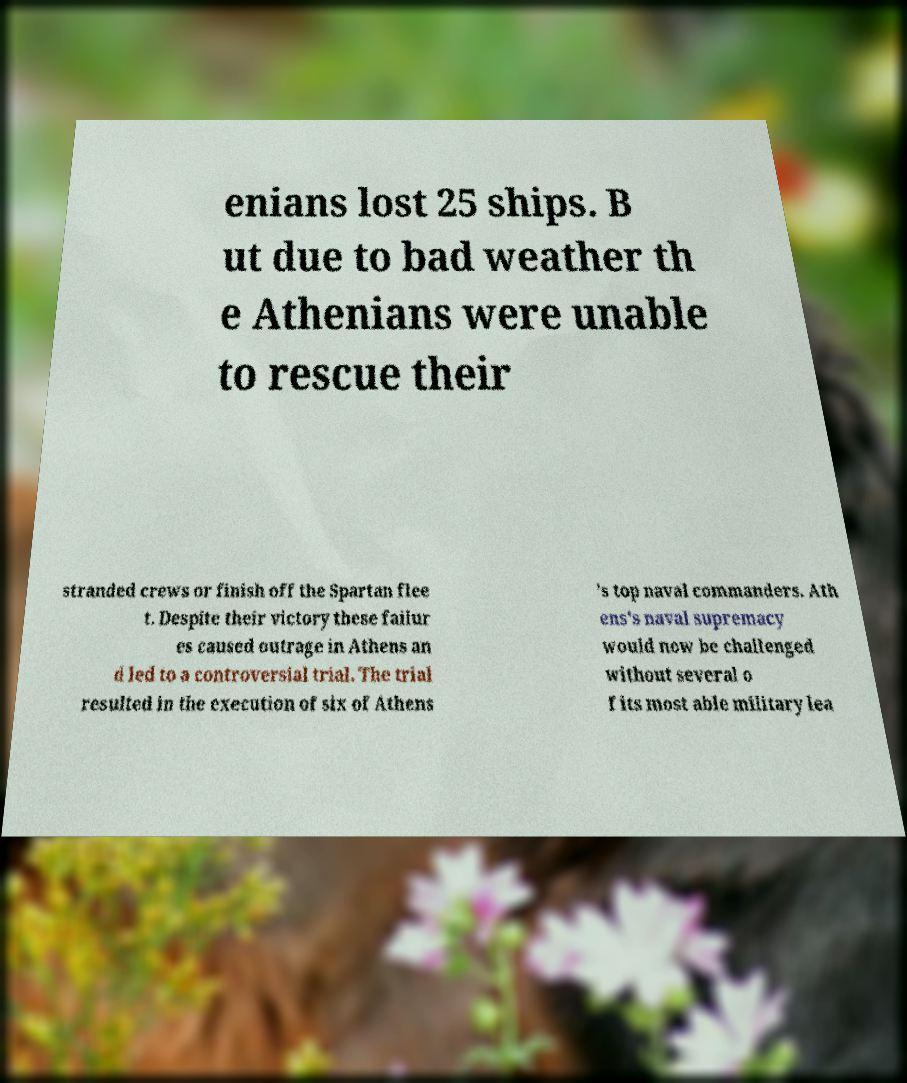Can you read and provide the text displayed in the image?This photo seems to have some interesting text. Can you extract and type it out for me? enians lost 25 ships. B ut due to bad weather th e Athenians were unable to rescue their stranded crews or finish off the Spartan flee t. Despite their victory these failur es caused outrage in Athens an d led to a controversial trial. The trial resulted in the execution of six of Athens 's top naval commanders. Ath ens's naval supremacy would now be challenged without several o f its most able military lea 